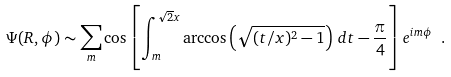<formula> <loc_0><loc_0><loc_500><loc_500>\Psi ( R , \phi ) \sim \sum _ { m } \cos \left [ \int _ { m } ^ { \sqrt { 2 } x } \arccos \left ( \sqrt { ( t / x ) ^ { 2 } - 1 } \right ) \, d t - \frac { \pi } { 4 } \right ] e ^ { i m \phi } \ .</formula> 